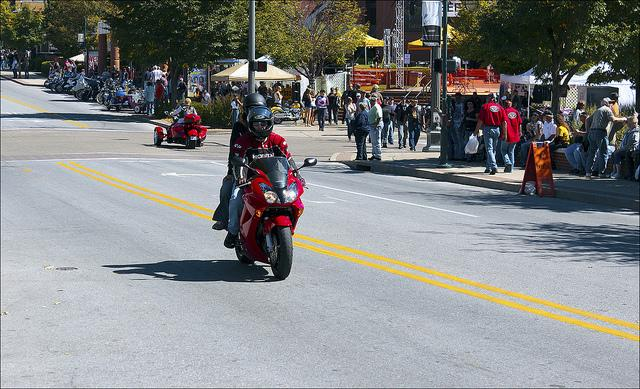What type of vehicles are most shown here? Please explain your reasoning. motorcycles. The vehicles are motorbikes. 